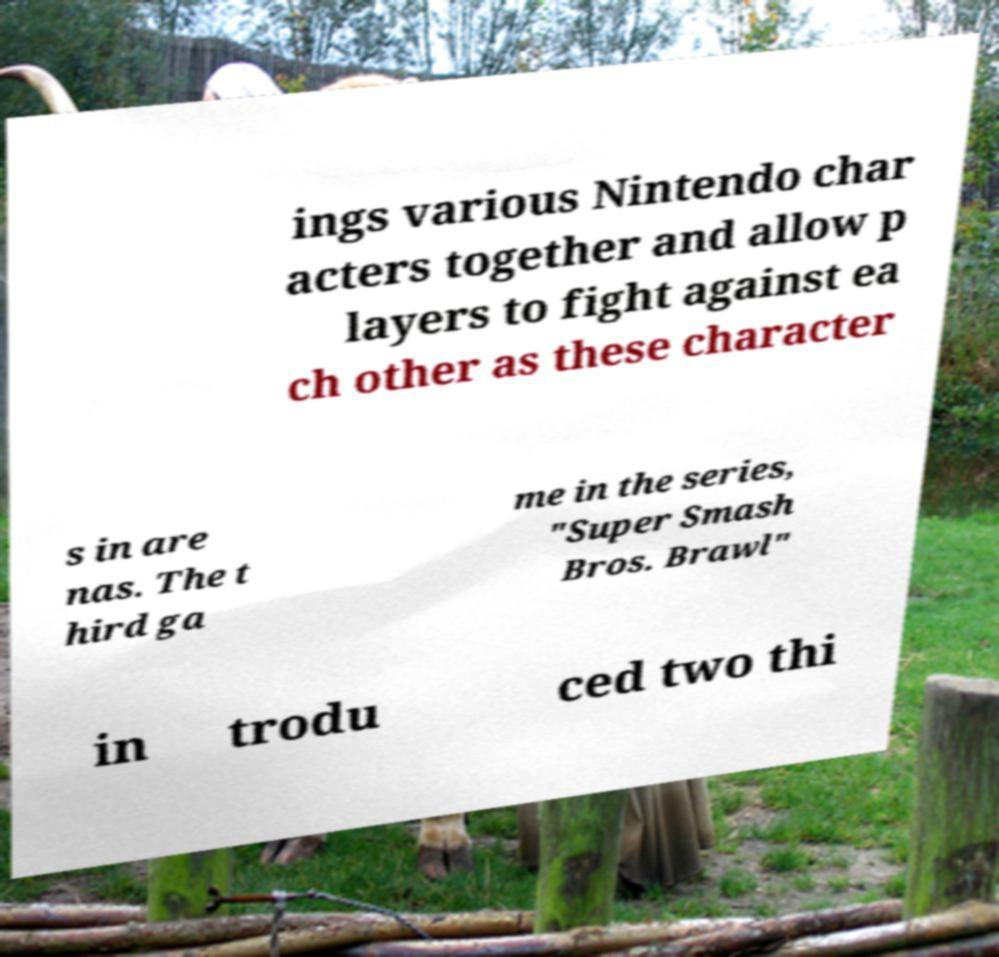Please read and relay the text visible in this image. What does it say? ings various Nintendo char acters together and allow p layers to fight against ea ch other as these character s in are nas. The t hird ga me in the series, "Super Smash Bros. Brawl" in trodu ced two thi 